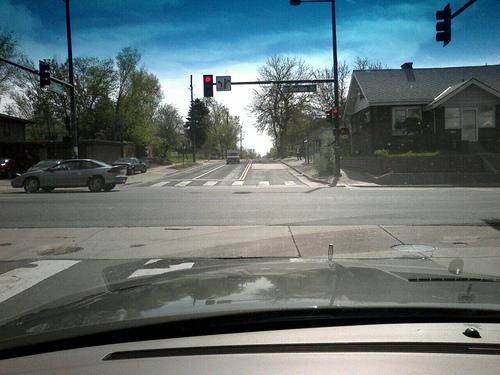Are the traffic lights working?
Answer briefly. Yes. What color is the traffic light?
Short answer required. Red. What kind of sign is in the background?
Answer briefly. Street sign. Are there people waiting to cross the street?
Short answer required. No. How many cars are there?
Short answer required. 4. 